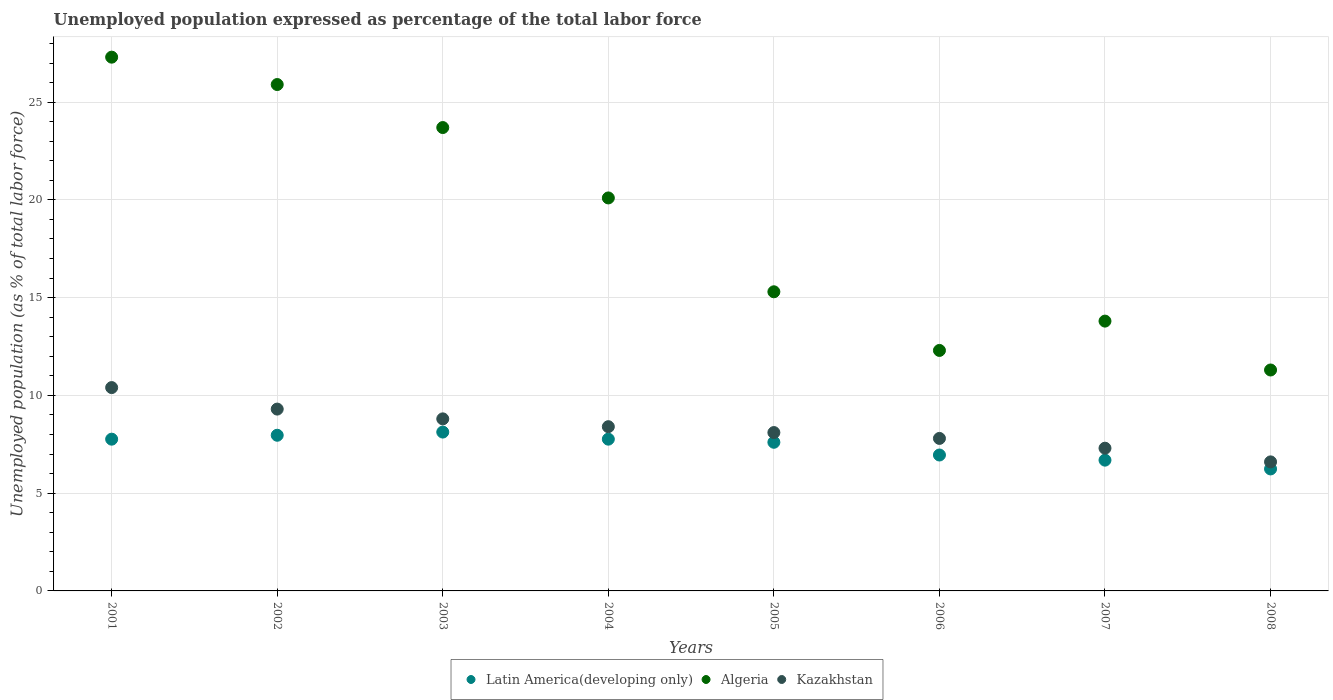How many different coloured dotlines are there?
Keep it short and to the point. 3. Is the number of dotlines equal to the number of legend labels?
Ensure brevity in your answer.  Yes. What is the unemployment in in Latin America(developing only) in 2008?
Your answer should be compact. 6.24. Across all years, what is the maximum unemployment in in Algeria?
Your answer should be very brief. 27.3. Across all years, what is the minimum unemployment in in Algeria?
Give a very brief answer. 11.3. What is the total unemployment in in Latin America(developing only) in the graph?
Provide a short and direct response. 59.09. What is the difference between the unemployment in in Latin America(developing only) in 2004 and that in 2005?
Offer a terse response. 0.16. What is the difference between the unemployment in in Kazakhstan in 2006 and the unemployment in in Algeria in 2002?
Offer a very short reply. -18.1. What is the average unemployment in in Latin America(developing only) per year?
Your response must be concise. 7.39. In the year 2003, what is the difference between the unemployment in in Algeria and unemployment in in Kazakhstan?
Keep it short and to the point. 14.9. In how many years, is the unemployment in in Algeria greater than 15 %?
Your response must be concise. 5. What is the ratio of the unemployment in in Algeria in 2005 to that in 2008?
Offer a terse response. 1.35. Is the difference between the unemployment in in Algeria in 2001 and 2007 greater than the difference between the unemployment in in Kazakhstan in 2001 and 2007?
Provide a succinct answer. Yes. What is the difference between the highest and the second highest unemployment in in Algeria?
Make the answer very short. 1.4. What is the difference between the highest and the lowest unemployment in in Kazakhstan?
Make the answer very short. 3.8. In how many years, is the unemployment in in Algeria greater than the average unemployment in in Algeria taken over all years?
Provide a short and direct response. 4. Is the unemployment in in Latin America(developing only) strictly greater than the unemployment in in Kazakhstan over the years?
Your answer should be very brief. No. How many dotlines are there?
Provide a short and direct response. 3. Does the graph contain any zero values?
Your answer should be very brief. No. Does the graph contain grids?
Offer a terse response. Yes. Where does the legend appear in the graph?
Your answer should be very brief. Bottom center. How are the legend labels stacked?
Provide a succinct answer. Horizontal. What is the title of the graph?
Offer a very short reply. Unemployed population expressed as percentage of the total labor force. What is the label or title of the X-axis?
Your response must be concise. Years. What is the label or title of the Y-axis?
Your answer should be compact. Unemployed population (as % of total labor force). What is the Unemployed population (as % of total labor force) of Latin America(developing only) in 2001?
Your answer should be compact. 7.76. What is the Unemployed population (as % of total labor force) of Algeria in 2001?
Provide a succinct answer. 27.3. What is the Unemployed population (as % of total labor force) in Kazakhstan in 2001?
Provide a short and direct response. 10.4. What is the Unemployed population (as % of total labor force) in Latin America(developing only) in 2002?
Make the answer very short. 7.96. What is the Unemployed population (as % of total labor force) of Algeria in 2002?
Offer a terse response. 25.9. What is the Unemployed population (as % of total labor force) of Kazakhstan in 2002?
Ensure brevity in your answer.  9.3. What is the Unemployed population (as % of total labor force) in Latin America(developing only) in 2003?
Make the answer very short. 8.12. What is the Unemployed population (as % of total labor force) of Algeria in 2003?
Your answer should be compact. 23.7. What is the Unemployed population (as % of total labor force) in Kazakhstan in 2003?
Provide a succinct answer. 8.8. What is the Unemployed population (as % of total labor force) of Latin America(developing only) in 2004?
Give a very brief answer. 7.76. What is the Unemployed population (as % of total labor force) of Algeria in 2004?
Provide a short and direct response. 20.1. What is the Unemployed population (as % of total labor force) of Kazakhstan in 2004?
Make the answer very short. 8.4. What is the Unemployed population (as % of total labor force) of Latin America(developing only) in 2005?
Your answer should be compact. 7.6. What is the Unemployed population (as % of total labor force) of Algeria in 2005?
Offer a terse response. 15.3. What is the Unemployed population (as % of total labor force) in Kazakhstan in 2005?
Offer a terse response. 8.1. What is the Unemployed population (as % of total labor force) of Latin America(developing only) in 2006?
Your answer should be compact. 6.95. What is the Unemployed population (as % of total labor force) of Algeria in 2006?
Your answer should be compact. 12.3. What is the Unemployed population (as % of total labor force) in Kazakhstan in 2006?
Give a very brief answer. 7.8. What is the Unemployed population (as % of total labor force) of Latin America(developing only) in 2007?
Ensure brevity in your answer.  6.69. What is the Unemployed population (as % of total labor force) of Algeria in 2007?
Provide a short and direct response. 13.8. What is the Unemployed population (as % of total labor force) in Kazakhstan in 2007?
Make the answer very short. 7.3. What is the Unemployed population (as % of total labor force) of Latin America(developing only) in 2008?
Your response must be concise. 6.24. What is the Unemployed population (as % of total labor force) of Algeria in 2008?
Ensure brevity in your answer.  11.3. What is the Unemployed population (as % of total labor force) in Kazakhstan in 2008?
Offer a very short reply. 6.6. Across all years, what is the maximum Unemployed population (as % of total labor force) of Latin America(developing only)?
Provide a short and direct response. 8.12. Across all years, what is the maximum Unemployed population (as % of total labor force) of Algeria?
Your answer should be very brief. 27.3. Across all years, what is the maximum Unemployed population (as % of total labor force) of Kazakhstan?
Give a very brief answer. 10.4. Across all years, what is the minimum Unemployed population (as % of total labor force) of Latin America(developing only)?
Offer a very short reply. 6.24. Across all years, what is the minimum Unemployed population (as % of total labor force) of Algeria?
Ensure brevity in your answer.  11.3. Across all years, what is the minimum Unemployed population (as % of total labor force) in Kazakhstan?
Give a very brief answer. 6.6. What is the total Unemployed population (as % of total labor force) in Latin America(developing only) in the graph?
Keep it short and to the point. 59.09. What is the total Unemployed population (as % of total labor force) of Algeria in the graph?
Keep it short and to the point. 149.7. What is the total Unemployed population (as % of total labor force) of Kazakhstan in the graph?
Ensure brevity in your answer.  66.7. What is the difference between the Unemployed population (as % of total labor force) in Latin America(developing only) in 2001 and that in 2002?
Your answer should be very brief. -0.2. What is the difference between the Unemployed population (as % of total labor force) in Latin America(developing only) in 2001 and that in 2003?
Offer a terse response. -0.36. What is the difference between the Unemployed population (as % of total labor force) in Kazakhstan in 2001 and that in 2003?
Keep it short and to the point. 1.6. What is the difference between the Unemployed population (as % of total labor force) of Latin America(developing only) in 2001 and that in 2004?
Your response must be concise. -0. What is the difference between the Unemployed population (as % of total labor force) of Latin America(developing only) in 2001 and that in 2005?
Keep it short and to the point. 0.16. What is the difference between the Unemployed population (as % of total labor force) in Kazakhstan in 2001 and that in 2005?
Ensure brevity in your answer.  2.3. What is the difference between the Unemployed population (as % of total labor force) of Latin America(developing only) in 2001 and that in 2006?
Your answer should be compact. 0.81. What is the difference between the Unemployed population (as % of total labor force) of Algeria in 2001 and that in 2006?
Give a very brief answer. 15. What is the difference between the Unemployed population (as % of total labor force) of Latin America(developing only) in 2001 and that in 2007?
Your response must be concise. 1.07. What is the difference between the Unemployed population (as % of total labor force) in Kazakhstan in 2001 and that in 2007?
Ensure brevity in your answer.  3.1. What is the difference between the Unemployed population (as % of total labor force) of Latin America(developing only) in 2001 and that in 2008?
Offer a very short reply. 1.52. What is the difference between the Unemployed population (as % of total labor force) of Algeria in 2001 and that in 2008?
Provide a short and direct response. 16. What is the difference between the Unemployed population (as % of total labor force) of Kazakhstan in 2001 and that in 2008?
Your answer should be compact. 3.8. What is the difference between the Unemployed population (as % of total labor force) in Latin America(developing only) in 2002 and that in 2003?
Provide a succinct answer. -0.16. What is the difference between the Unemployed population (as % of total labor force) in Algeria in 2002 and that in 2003?
Give a very brief answer. 2.2. What is the difference between the Unemployed population (as % of total labor force) in Kazakhstan in 2002 and that in 2003?
Give a very brief answer. 0.5. What is the difference between the Unemployed population (as % of total labor force) of Latin America(developing only) in 2002 and that in 2004?
Provide a short and direct response. 0.2. What is the difference between the Unemployed population (as % of total labor force) of Algeria in 2002 and that in 2004?
Keep it short and to the point. 5.8. What is the difference between the Unemployed population (as % of total labor force) in Latin America(developing only) in 2002 and that in 2005?
Your answer should be compact. 0.36. What is the difference between the Unemployed population (as % of total labor force) of Latin America(developing only) in 2002 and that in 2006?
Your answer should be very brief. 1.01. What is the difference between the Unemployed population (as % of total labor force) of Kazakhstan in 2002 and that in 2006?
Offer a very short reply. 1.5. What is the difference between the Unemployed population (as % of total labor force) of Latin America(developing only) in 2002 and that in 2007?
Make the answer very short. 1.27. What is the difference between the Unemployed population (as % of total labor force) in Kazakhstan in 2002 and that in 2007?
Ensure brevity in your answer.  2. What is the difference between the Unemployed population (as % of total labor force) in Latin America(developing only) in 2002 and that in 2008?
Provide a short and direct response. 1.72. What is the difference between the Unemployed population (as % of total labor force) of Algeria in 2002 and that in 2008?
Give a very brief answer. 14.6. What is the difference between the Unemployed population (as % of total labor force) in Latin America(developing only) in 2003 and that in 2004?
Offer a terse response. 0.36. What is the difference between the Unemployed population (as % of total labor force) of Kazakhstan in 2003 and that in 2004?
Ensure brevity in your answer.  0.4. What is the difference between the Unemployed population (as % of total labor force) in Latin America(developing only) in 2003 and that in 2005?
Keep it short and to the point. 0.52. What is the difference between the Unemployed population (as % of total labor force) in Kazakhstan in 2003 and that in 2005?
Make the answer very short. 0.7. What is the difference between the Unemployed population (as % of total labor force) in Latin America(developing only) in 2003 and that in 2006?
Ensure brevity in your answer.  1.17. What is the difference between the Unemployed population (as % of total labor force) in Latin America(developing only) in 2003 and that in 2007?
Provide a short and direct response. 1.44. What is the difference between the Unemployed population (as % of total labor force) in Algeria in 2003 and that in 2007?
Offer a very short reply. 9.9. What is the difference between the Unemployed population (as % of total labor force) in Latin America(developing only) in 2003 and that in 2008?
Your response must be concise. 1.89. What is the difference between the Unemployed population (as % of total labor force) in Algeria in 2003 and that in 2008?
Your answer should be very brief. 12.4. What is the difference between the Unemployed population (as % of total labor force) in Latin America(developing only) in 2004 and that in 2005?
Your answer should be very brief. 0.16. What is the difference between the Unemployed population (as % of total labor force) in Algeria in 2004 and that in 2005?
Give a very brief answer. 4.8. What is the difference between the Unemployed population (as % of total labor force) in Kazakhstan in 2004 and that in 2005?
Your response must be concise. 0.3. What is the difference between the Unemployed population (as % of total labor force) in Latin America(developing only) in 2004 and that in 2006?
Offer a terse response. 0.81. What is the difference between the Unemployed population (as % of total labor force) of Kazakhstan in 2004 and that in 2006?
Give a very brief answer. 0.6. What is the difference between the Unemployed population (as % of total labor force) in Latin America(developing only) in 2004 and that in 2007?
Your answer should be compact. 1.07. What is the difference between the Unemployed population (as % of total labor force) of Algeria in 2004 and that in 2007?
Offer a terse response. 6.3. What is the difference between the Unemployed population (as % of total labor force) in Latin America(developing only) in 2004 and that in 2008?
Offer a very short reply. 1.52. What is the difference between the Unemployed population (as % of total labor force) of Latin America(developing only) in 2005 and that in 2006?
Your answer should be compact. 0.65. What is the difference between the Unemployed population (as % of total labor force) of Algeria in 2005 and that in 2006?
Provide a succinct answer. 3. What is the difference between the Unemployed population (as % of total labor force) of Latin America(developing only) in 2005 and that in 2007?
Keep it short and to the point. 0.91. What is the difference between the Unemployed population (as % of total labor force) of Algeria in 2005 and that in 2007?
Your response must be concise. 1.5. What is the difference between the Unemployed population (as % of total labor force) of Latin America(developing only) in 2005 and that in 2008?
Provide a succinct answer. 1.36. What is the difference between the Unemployed population (as % of total labor force) of Algeria in 2005 and that in 2008?
Offer a very short reply. 4. What is the difference between the Unemployed population (as % of total labor force) in Latin America(developing only) in 2006 and that in 2007?
Your response must be concise. 0.26. What is the difference between the Unemployed population (as % of total labor force) of Kazakhstan in 2006 and that in 2007?
Offer a terse response. 0.5. What is the difference between the Unemployed population (as % of total labor force) of Latin America(developing only) in 2006 and that in 2008?
Provide a succinct answer. 0.71. What is the difference between the Unemployed population (as % of total labor force) in Algeria in 2006 and that in 2008?
Offer a very short reply. 1. What is the difference between the Unemployed population (as % of total labor force) of Latin America(developing only) in 2007 and that in 2008?
Provide a succinct answer. 0.45. What is the difference between the Unemployed population (as % of total labor force) in Kazakhstan in 2007 and that in 2008?
Provide a succinct answer. 0.7. What is the difference between the Unemployed population (as % of total labor force) of Latin America(developing only) in 2001 and the Unemployed population (as % of total labor force) of Algeria in 2002?
Your answer should be very brief. -18.14. What is the difference between the Unemployed population (as % of total labor force) of Latin America(developing only) in 2001 and the Unemployed population (as % of total labor force) of Kazakhstan in 2002?
Offer a terse response. -1.54. What is the difference between the Unemployed population (as % of total labor force) in Latin America(developing only) in 2001 and the Unemployed population (as % of total labor force) in Algeria in 2003?
Your answer should be compact. -15.94. What is the difference between the Unemployed population (as % of total labor force) of Latin America(developing only) in 2001 and the Unemployed population (as % of total labor force) of Kazakhstan in 2003?
Your answer should be compact. -1.04. What is the difference between the Unemployed population (as % of total labor force) in Latin America(developing only) in 2001 and the Unemployed population (as % of total labor force) in Algeria in 2004?
Offer a terse response. -12.34. What is the difference between the Unemployed population (as % of total labor force) in Latin America(developing only) in 2001 and the Unemployed population (as % of total labor force) in Kazakhstan in 2004?
Keep it short and to the point. -0.64. What is the difference between the Unemployed population (as % of total labor force) in Algeria in 2001 and the Unemployed population (as % of total labor force) in Kazakhstan in 2004?
Provide a short and direct response. 18.9. What is the difference between the Unemployed population (as % of total labor force) of Latin America(developing only) in 2001 and the Unemployed population (as % of total labor force) of Algeria in 2005?
Make the answer very short. -7.54. What is the difference between the Unemployed population (as % of total labor force) in Latin America(developing only) in 2001 and the Unemployed population (as % of total labor force) in Kazakhstan in 2005?
Make the answer very short. -0.34. What is the difference between the Unemployed population (as % of total labor force) of Algeria in 2001 and the Unemployed population (as % of total labor force) of Kazakhstan in 2005?
Your answer should be compact. 19.2. What is the difference between the Unemployed population (as % of total labor force) in Latin America(developing only) in 2001 and the Unemployed population (as % of total labor force) in Algeria in 2006?
Ensure brevity in your answer.  -4.54. What is the difference between the Unemployed population (as % of total labor force) of Latin America(developing only) in 2001 and the Unemployed population (as % of total labor force) of Kazakhstan in 2006?
Ensure brevity in your answer.  -0.04. What is the difference between the Unemployed population (as % of total labor force) in Algeria in 2001 and the Unemployed population (as % of total labor force) in Kazakhstan in 2006?
Make the answer very short. 19.5. What is the difference between the Unemployed population (as % of total labor force) in Latin America(developing only) in 2001 and the Unemployed population (as % of total labor force) in Algeria in 2007?
Offer a very short reply. -6.04. What is the difference between the Unemployed population (as % of total labor force) in Latin America(developing only) in 2001 and the Unemployed population (as % of total labor force) in Kazakhstan in 2007?
Provide a short and direct response. 0.46. What is the difference between the Unemployed population (as % of total labor force) of Algeria in 2001 and the Unemployed population (as % of total labor force) of Kazakhstan in 2007?
Provide a short and direct response. 20. What is the difference between the Unemployed population (as % of total labor force) in Latin America(developing only) in 2001 and the Unemployed population (as % of total labor force) in Algeria in 2008?
Your answer should be very brief. -3.54. What is the difference between the Unemployed population (as % of total labor force) in Latin America(developing only) in 2001 and the Unemployed population (as % of total labor force) in Kazakhstan in 2008?
Keep it short and to the point. 1.16. What is the difference between the Unemployed population (as % of total labor force) of Algeria in 2001 and the Unemployed population (as % of total labor force) of Kazakhstan in 2008?
Offer a terse response. 20.7. What is the difference between the Unemployed population (as % of total labor force) in Latin America(developing only) in 2002 and the Unemployed population (as % of total labor force) in Algeria in 2003?
Offer a terse response. -15.74. What is the difference between the Unemployed population (as % of total labor force) of Latin America(developing only) in 2002 and the Unemployed population (as % of total labor force) of Kazakhstan in 2003?
Your answer should be very brief. -0.84. What is the difference between the Unemployed population (as % of total labor force) of Latin America(developing only) in 2002 and the Unemployed population (as % of total labor force) of Algeria in 2004?
Make the answer very short. -12.14. What is the difference between the Unemployed population (as % of total labor force) in Latin America(developing only) in 2002 and the Unemployed population (as % of total labor force) in Kazakhstan in 2004?
Ensure brevity in your answer.  -0.44. What is the difference between the Unemployed population (as % of total labor force) of Algeria in 2002 and the Unemployed population (as % of total labor force) of Kazakhstan in 2004?
Your response must be concise. 17.5. What is the difference between the Unemployed population (as % of total labor force) in Latin America(developing only) in 2002 and the Unemployed population (as % of total labor force) in Algeria in 2005?
Your response must be concise. -7.34. What is the difference between the Unemployed population (as % of total labor force) of Latin America(developing only) in 2002 and the Unemployed population (as % of total labor force) of Kazakhstan in 2005?
Your response must be concise. -0.14. What is the difference between the Unemployed population (as % of total labor force) in Latin America(developing only) in 2002 and the Unemployed population (as % of total labor force) in Algeria in 2006?
Ensure brevity in your answer.  -4.34. What is the difference between the Unemployed population (as % of total labor force) in Latin America(developing only) in 2002 and the Unemployed population (as % of total labor force) in Kazakhstan in 2006?
Provide a short and direct response. 0.16. What is the difference between the Unemployed population (as % of total labor force) in Algeria in 2002 and the Unemployed population (as % of total labor force) in Kazakhstan in 2006?
Make the answer very short. 18.1. What is the difference between the Unemployed population (as % of total labor force) in Latin America(developing only) in 2002 and the Unemployed population (as % of total labor force) in Algeria in 2007?
Provide a succinct answer. -5.84. What is the difference between the Unemployed population (as % of total labor force) in Latin America(developing only) in 2002 and the Unemployed population (as % of total labor force) in Kazakhstan in 2007?
Provide a succinct answer. 0.66. What is the difference between the Unemployed population (as % of total labor force) of Algeria in 2002 and the Unemployed population (as % of total labor force) of Kazakhstan in 2007?
Your answer should be very brief. 18.6. What is the difference between the Unemployed population (as % of total labor force) in Latin America(developing only) in 2002 and the Unemployed population (as % of total labor force) in Algeria in 2008?
Your answer should be compact. -3.34. What is the difference between the Unemployed population (as % of total labor force) of Latin America(developing only) in 2002 and the Unemployed population (as % of total labor force) of Kazakhstan in 2008?
Your response must be concise. 1.36. What is the difference between the Unemployed population (as % of total labor force) in Algeria in 2002 and the Unemployed population (as % of total labor force) in Kazakhstan in 2008?
Your answer should be very brief. 19.3. What is the difference between the Unemployed population (as % of total labor force) of Latin America(developing only) in 2003 and the Unemployed population (as % of total labor force) of Algeria in 2004?
Keep it short and to the point. -11.98. What is the difference between the Unemployed population (as % of total labor force) of Latin America(developing only) in 2003 and the Unemployed population (as % of total labor force) of Kazakhstan in 2004?
Provide a short and direct response. -0.28. What is the difference between the Unemployed population (as % of total labor force) of Algeria in 2003 and the Unemployed population (as % of total labor force) of Kazakhstan in 2004?
Your answer should be very brief. 15.3. What is the difference between the Unemployed population (as % of total labor force) in Latin America(developing only) in 2003 and the Unemployed population (as % of total labor force) in Algeria in 2005?
Give a very brief answer. -7.18. What is the difference between the Unemployed population (as % of total labor force) in Latin America(developing only) in 2003 and the Unemployed population (as % of total labor force) in Kazakhstan in 2005?
Offer a terse response. 0.02. What is the difference between the Unemployed population (as % of total labor force) in Latin America(developing only) in 2003 and the Unemployed population (as % of total labor force) in Algeria in 2006?
Make the answer very short. -4.18. What is the difference between the Unemployed population (as % of total labor force) of Latin America(developing only) in 2003 and the Unemployed population (as % of total labor force) of Kazakhstan in 2006?
Offer a terse response. 0.32. What is the difference between the Unemployed population (as % of total labor force) in Latin America(developing only) in 2003 and the Unemployed population (as % of total labor force) in Algeria in 2007?
Ensure brevity in your answer.  -5.68. What is the difference between the Unemployed population (as % of total labor force) in Latin America(developing only) in 2003 and the Unemployed population (as % of total labor force) in Kazakhstan in 2007?
Offer a terse response. 0.82. What is the difference between the Unemployed population (as % of total labor force) in Latin America(developing only) in 2003 and the Unemployed population (as % of total labor force) in Algeria in 2008?
Give a very brief answer. -3.18. What is the difference between the Unemployed population (as % of total labor force) of Latin America(developing only) in 2003 and the Unemployed population (as % of total labor force) of Kazakhstan in 2008?
Provide a succinct answer. 1.52. What is the difference between the Unemployed population (as % of total labor force) in Algeria in 2003 and the Unemployed population (as % of total labor force) in Kazakhstan in 2008?
Make the answer very short. 17.1. What is the difference between the Unemployed population (as % of total labor force) in Latin America(developing only) in 2004 and the Unemployed population (as % of total labor force) in Algeria in 2005?
Provide a succinct answer. -7.54. What is the difference between the Unemployed population (as % of total labor force) in Latin America(developing only) in 2004 and the Unemployed population (as % of total labor force) in Kazakhstan in 2005?
Provide a short and direct response. -0.34. What is the difference between the Unemployed population (as % of total labor force) of Latin America(developing only) in 2004 and the Unemployed population (as % of total labor force) of Algeria in 2006?
Your response must be concise. -4.54. What is the difference between the Unemployed population (as % of total labor force) of Latin America(developing only) in 2004 and the Unemployed population (as % of total labor force) of Kazakhstan in 2006?
Offer a very short reply. -0.04. What is the difference between the Unemployed population (as % of total labor force) of Algeria in 2004 and the Unemployed population (as % of total labor force) of Kazakhstan in 2006?
Keep it short and to the point. 12.3. What is the difference between the Unemployed population (as % of total labor force) in Latin America(developing only) in 2004 and the Unemployed population (as % of total labor force) in Algeria in 2007?
Offer a very short reply. -6.04. What is the difference between the Unemployed population (as % of total labor force) of Latin America(developing only) in 2004 and the Unemployed population (as % of total labor force) of Kazakhstan in 2007?
Offer a terse response. 0.46. What is the difference between the Unemployed population (as % of total labor force) of Algeria in 2004 and the Unemployed population (as % of total labor force) of Kazakhstan in 2007?
Ensure brevity in your answer.  12.8. What is the difference between the Unemployed population (as % of total labor force) of Latin America(developing only) in 2004 and the Unemployed population (as % of total labor force) of Algeria in 2008?
Provide a short and direct response. -3.54. What is the difference between the Unemployed population (as % of total labor force) in Latin America(developing only) in 2004 and the Unemployed population (as % of total labor force) in Kazakhstan in 2008?
Give a very brief answer. 1.16. What is the difference between the Unemployed population (as % of total labor force) in Algeria in 2004 and the Unemployed population (as % of total labor force) in Kazakhstan in 2008?
Provide a short and direct response. 13.5. What is the difference between the Unemployed population (as % of total labor force) of Latin America(developing only) in 2005 and the Unemployed population (as % of total labor force) of Algeria in 2006?
Make the answer very short. -4.7. What is the difference between the Unemployed population (as % of total labor force) of Latin America(developing only) in 2005 and the Unemployed population (as % of total labor force) of Kazakhstan in 2006?
Keep it short and to the point. -0.2. What is the difference between the Unemployed population (as % of total labor force) of Latin America(developing only) in 2005 and the Unemployed population (as % of total labor force) of Algeria in 2007?
Your answer should be compact. -6.2. What is the difference between the Unemployed population (as % of total labor force) in Latin America(developing only) in 2005 and the Unemployed population (as % of total labor force) in Kazakhstan in 2007?
Your response must be concise. 0.3. What is the difference between the Unemployed population (as % of total labor force) in Algeria in 2005 and the Unemployed population (as % of total labor force) in Kazakhstan in 2007?
Your answer should be compact. 8. What is the difference between the Unemployed population (as % of total labor force) in Latin America(developing only) in 2005 and the Unemployed population (as % of total labor force) in Algeria in 2008?
Your response must be concise. -3.7. What is the difference between the Unemployed population (as % of total labor force) in Latin America(developing only) in 2006 and the Unemployed population (as % of total labor force) in Algeria in 2007?
Ensure brevity in your answer.  -6.85. What is the difference between the Unemployed population (as % of total labor force) in Latin America(developing only) in 2006 and the Unemployed population (as % of total labor force) in Kazakhstan in 2007?
Ensure brevity in your answer.  -0.35. What is the difference between the Unemployed population (as % of total labor force) in Algeria in 2006 and the Unemployed population (as % of total labor force) in Kazakhstan in 2007?
Your answer should be compact. 5. What is the difference between the Unemployed population (as % of total labor force) of Latin America(developing only) in 2006 and the Unemployed population (as % of total labor force) of Algeria in 2008?
Your answer should be very brief. -4.35. What is the difference between the Unemployed population (as % of total labor force) in Latin America(developing only) in 2006 and the Unemployed population (as % of total labor force) in Kazakhstan in 2008?
Your response must be concise. 0.35. What is the difference between the Unemployed population (as % of total labor force) in Algeria in 2006 and the Unemployed population (as % of total labor force) in Kazakhstan in 2008?
Your answer should be compact. 5.7. What is the difference between the Unemployed population (as % of total labor force) in Latin America(developing only) in 2007 and the Unemployed population (as % of total labor force) in Algeria in 2008?
Give a very brief answer. -4.61. What is the difference between the Unemployed population (as % of total labor force) in Latin America(developing only) in 2007 and the Unemployed population (as % of total labor force) in Kazakhstan in 2008?
Offer a terse response. 0.09. What is the difference between the Unemployed population (as % of total labor force) in Algeria in 2007 and the Unemployed population (as % of total labor force) in Kazakhstan in 2008?
Offer a very short reply. 7.2. What is the average Unemployed population (as % of total labor force) in Latin America(developing only) per year?
Provide a succinct answer. 7.39. What is the average Unemployed population (as % of total labor force) in Algeria per year?
Your response must be concise. 18.71. What is the average Unemployed population (as % of total labor force) in Kazakhstan per year?
Your answer should be very brief. 8.34. In the year 2001, what is the difference between the Unemployed population (as % of total labor force) in Latin America(developing only) and Unemployed population (as % of total labor force) in Algeria?
Make the answer very short. -19.54. In the year 2001, what is the difference between the Unemployed population (as % of total labor force) of Latin America(developing only) and Unemployed population (as % of total labor force) of Kazakhstan?
Make the answer very short. -2.64. In the year 2002, what is the difference between the Unemployed population (as % of total labor force) of Latin America(developing only) and Unemployed population (as % of total labor force) of Algeria?
Your answer should be very brief. -17.94. In the year 2002, what is the difference between the Unemployed population (as % of total labor force) of Latin America(developing only) and Unemployed population (as % of total labor force) of Kazakhstan?
Your answer should be very brief. -1.34. In the year 2002, what is the difference between the Unemployed population (as % of total labor force) of Algeria and Unemployed population (as % of total labor force) of Kazakhstan?
Keep it short and to the point. 16.6. In the year 2003, what is the difference between the Unemployed population (as % of total labor force) of Latin America(developing only) and Unemployed population (as % of total labor force) of Algeria?
Offer a very short reply. -15.58. In the year 2003, what is the difference between the Unemployed population (as % of total labor force) of Latin America(developing only) and Unemployed population (as % of total labor force) of Kazakhstan?
Offer a terse response. -0.68. In the year 2003, what is the difference between the Unemployed population (as % of total labor force) of Algeria and Unemployed population (as % of total labor force) of Kazakhstan?
Make the answer very short. 14.9. In the year 2004, what is the difference between the Unemployed population (as % of total labor force) in Latin America(developing only) and Unemployed population (as % of total labor force) in Algeria?
Keep it short and to the point. -12.34. In the year 2004, what is the difference between the Unemployed population (as % of total labor force) of Latin America(developing only) and Unemployed population (as % of total labor force) of Kazakhstan?
Keep it short and to the point. -0.64. In the year 2005, what is the difference between the Unemployed population (as % of total labor force) in Latin America(developing only) and Unemployed population (as % of total labor force) in Algeria?
Ensure brevity in your answer.  -7.7. In the year 2005, what is the difference between the Unemployed population (as % of total labor force) of Latin America(developing only) and Unemployed population (as % of total labor force) of Kazakhstan?
Provide a succinct answer. -0.5. In the year 2006, what is the difference between the Unemployed population (as % of total labor force) of Latin America(developing only) and Unemployed population (as % of total labor force) of Algeria?
Your response must be concise. -5.35. In the year 2006, what is the difference between the Unemployed population (as % of total labor force) of Latin America(developing only) and Unemployed population (as % of total labor force) of Kazakhstan?
Keep it short and to the point. -0.85. In the year 2006, what is the difference between the Unemployed population (as % of total labor force) in Algeria and Unemployed population (as % of total labor force) in Kazakhstan?
Provide a succinct answer. 4.5. In the year 2007, what is the difference between the Unemployed population (as % of total labor force) in Latin America(developing only) and Unemployed population (as % of total labor force) in Algeria?
Offer a terse response. -7.11. In the year 2007, what is the difference between the Unemployed population (as % of total labor force) in Latin America(developing only) and Unemployed population (as % of total labor force) in Kazakhstan?
Your response must be concise. -0.61. In the year 2008, what is the difference between the Unemployed population (as % of total labor force) in Latin America(developing only) and Unemployed population (as % of total labor force) in Algeria?
Ensure brevity in your answer.  -5.06. In the year 2008, what is the difference between the Unemployed population (as % of total labor force) in Latin America(developing only) and Unemployed population (as % of total labor force) in Kazakhstan?
Provide a short and direct response. -0.36. What is the ratio of the Unemployed population (as % of total labor force) of Latin America(developing only) in 2001 to that in 2002?
Provide a short and direct response. 0.97. What is the ratio of the Unemployed population (as % of total labor force) in Algeria in 2001 to that in 2002?
Your answer should be very brief. 1.05. What is the ratio of the Unemployed population (as % of total labor force) of Kazakhstan in 2001 to that in 2002?
Your answer should be compact. 1.12. What is the ratio of the Unemployed population (as % of total labor force) of Latin America(developing only) in 2001 to that in 2003?
Your answer should be very brief. 0.96. What is the ratio of the Unemployed population (as % of total labor force) of Algeria in 2001 to that in 2003?
Offer a very short reply. 1.15. What is the ratio of the Unemployed population (as % of total labor force) of Kazakhstan in 2001 to that in 2003?
Your response must be concise. 1.18. What is the ratio of the Unemployed population (as % of total labor force) in Algeria in 2001 to that in 2004?
Your response must be concise. 1.36. What is the ratio of the Unemployed population (as % of total labor force) of Kazakhstan in 2001 to that in 2004?
Keep it short and to the point. 1.24. What is the ratio of the Unemployed population (as % of total labor force) of Latin America(developing only) in 2001 to that in 2005?
Your answer should be very brief. 1.02. What is the ratio of the Unemployed population (as % of total labor force) in Algeria in 2001 to that in 2005?
Give a very brief answer. 1.78. What is the ratio of the Unemployed population (as % of total labor force) of Kazakhstan in 2001 to that in 2005?
Your response must be concise. 1.28. What is the ratio of the Unemployed population (as % of total labor force) of Latin America(developing only) in 2001 to that in 2006?
Ensure brevity in your answer.  1.12. What is the ratio of the Unemployed population (as % of total labor force) of Algeria in 2001 to that in 2006?
Your answer should be compact. 2.22. What is the ratio of the Unemployed population (as % of total labor force) in Kazakhstan in 2001 to that in 2006?
Ensure brevity in your answer.  1.33. What is the ratio of the Unemployed population (as % of total labor force) of Latin America(developing only) in 2001 to that in 2007?
Keep it short and to the point. 1.16. What is the ratio of the Unemployed population (as % of total labor force) of Algeria in 2001 to that in 2007?
Provide a short and direct response. 1.98. What is the ratio of the Unemployed population (as % of total labor force) in Kazakhstan in 2001 to that in 2007?
Provide a short and direct response. 1.42. What is the ratio of the Unemployed population (as % of total labor force) of Latin America(developing only) in 2001 to that in 2008?
Your response must be concise. 1.24. What is the ratio of the Unemployed population (as % of total labor force) of Algeria in 2001 to that in 2008?
Your answer should be compact. 2.42. What is the ratio of the Unemployed population (as % of total labor force) of Kazakhstan in 2001 to that in 2008?
Your answer should be very brief. 1.58. What is the ratio of the Unemployed population (as % of total labor force) in Algeria in 2002 to that in 2003?
Offer a terse response. 1.09. What is the ratio of the Unemployed population (as % of total labor force) of Kazakhstan in 2002 to that in 2003?
Your response must be concise. 1.06. What is the ratio of the Unemployed population (as % of total labor force) in Latin America(developing only) in 2002 to that in 2004?
Offer a terse response. 1.03. What is the ratio of the Unemployed population (as % of total labor force) in Algeria in 2002 to that in 2004?
Provide a short and direct response. 1.29. What is the ratio of the Unemployed population (as % of total labor force) of Kazakhstan in 2002 to that in 2004?
Your answer should be compact. 1.11. What is the ratio of the Unemployed population (as % of total labor force) in Latin America(developing only) in 2002 to that in 2005?
Your answer should be very brief. 1.05. What is the ratio of the Unemployed population (as % of total labor force) of Algeria in 2002 to that in 2005?
Your answer should be very brief. 1.69. What is the ratio of the Unemployed population (as % of total labor force) in Kazakhstan in 2002 to that in 2005?
Your answer should be compact. 1.15. What is the ratio of the Unemployed population (as % of total labor force) in Latin America(developing only) in 2002 to that in 2006?
Offer a very short reply. 1.15. What is the ratio of the Unemployed population (as % of total labor force) of Algeria in 2002 to that in 2006?
Provide a succinct answer. 2.11. What is the ratio of the Unemployed population (as % of total labor force) of Kazakhstan in 2002 to that in 2006?
Give a very brief answer. 1.19. What is the ratio of the Unemployed population (as % of total labor force) of Latin America(developing only) in 2002 to that in 2007?
Offer a terse response. 1.19. What is the ratio of the Unemployed population (as % of total labor force) in Algeria in 2002 to that in 2007?
Offer a very short reply. 1.88. What is the ratio of the Unemployed population (as % of total labor force) of Kazakhstan in 2002 to that in 2007?
Offer a very short reply. 1.27. What is the ratio of the Unemployed population (as % of total labor force) of Latin America(developing only) in 2002 to that in 2008?
Offer a very short reply. 1.28. What is the ratio of the Unemployed population (as % of total labor force) of Algeria in 2002 to that in 2008?
Offer a very short reply. 2.29. What is the ratio of the Unemployed population (as % of total labor force) in Kazakhstan in 2002 to that in 2008?
Offer a terse response. 1.41. What is the ratio of the Unemployed population (as % of total labor force) in Latin America(developing only) in 2003 to that in 2004?
Your answer should be compact. 1.05. What is the ratio of the Unemployed population (as % of total labor force) in Algeria in 2003 to that in 2004?
Your response must be concise. 1.18. What is the ratio of the Unemployed population (as % of total labor force) of Kazakhstan in 2003 to that in 2004?
Give a very brief answer. 1.05. What is the ratio of the Unemployed population (as % of total labor force) of Latin America(developing only) in 2003 to that in 2005?
Offer a very short reply. 1.07. What is the ratio of the Unemployed population (as % of total labor force) of Algeria in 2003 to that in 2005?
Keep it short and to the point. 1.55. What is the ratio of the Unemployed population (as % of total labor force) in Kazakhstan in 2003 to that in 2005?
Offer a terse response. 1.09. What is the ratio of the Unemployed population (as % of total labor force) of Latin America(developing only) in 2003 to that in 2006?
Keep it short and to the point. 1.17. What is the ratio of the Unemployed population (as % of total labor force) in Algeria in 2003 to that in 2006?
Offer a terse response. 1.93. What is the ratio of the Unemployed population (as % of total labor force) of Kazakhstan in 2003 to that in 2006?
Provide a short and direct response. 1.13. What is the ratio of the Unemployed population (as % of total labor force) of Latin America(developing only) in 2003 to that in 2007?
Offer a very short reply. 1.21. What is the ratio of the Unemployed population (as % of total labor force) in Algeria in 2003 to that in 2007?
Provide a short and direct response. 1.72. What is the ratio of the Unemployed population (as % of total labor force) of Kazakhstan in 2003 to that in 2007?
Offer a terse response. 1.21. What is the ratio of the Unemployed population (as % of total labor force) of Latin America(developing only) in 2003 to that in 2008?
Your answer should be compact. 1.3. What is the ratio of the Unemployed population (as % of total labor force) in Algeria in 2003 to that in 2008?
Your answer should be compact. 2.1. What is the ratio of the Unemployed population (as % of total labor force) of Latin America(developing only) in 2004 to that in 2005?
Offer a terse response. 1.02. What is the ratio of the Unemployed population (as % of total labor force) in Algeria in 2004 to that in 2005?
Ensure brevity in your answer.  1.31. What is the ratio of the Unemployed population (as % of total labor force) in Latin America(developing only) in 2004 to that in 2006?
Make the answer very short. 1.12. What is the ratio of the Unemployed population (as % of total labor force) of Algeria in 2004 to that in 2006?
Ensure brevity in your answer.  1.63. What is the ratio of the Unemployed population (as % of total labor force) of Kazakhstan in 2004 to that in 2006?
Ensure brevity in your answer.  1.08. What is the ratio of the Unemployed population (as % of total labor force) of Latin America(developing only) in 2004 to that in 2007?
Offer a terse response. 1.16. What is the ratio of the Unemployed population (as % of total labor force) in Algeria in 2004 to that in 2007?
Offer a very short reply. 1.46. What is the ratio of the Unemployed population (as % of total labor force) of Kazakhstan in 2004 to that in 2007?
Your response must be concise. 1.15. What is the ratio of the Unemployed population (as % of total labor force) in Latin America(developing only) in 2004 to that in 2008?
Offer a very short reply. 1.24. What is the ratio of the Unemployed population (as % of total labor force) of Algeria in 2004 to that in 2008?
Give a very brief answer. 1.78. What is the ratio of the Unemployed population (as % of total labor force) of Kazakhstan in 2004 to that in 2008?
Your response must be concise. 1.27. What is the ratio of the Unemployed population (as % of total labor force) in Latin America(developing only) in 2005 to that in 2006?
Ensure brevity in your answer.  1.09. What is the ratio of the Unemployed population (as % of total labor force) of Algeria in 2005 to that in 2006?
Provide a succinct answer. 1.24. What is the ratio of the Unemployed population (as % of total labor force) of Latin America(developing only) in 2005 to that in 2007?
Ensure brevity in your answer.  1.14. What is the ratio of the Unemployed population (as % of total labor force) of Algeria in 2005 to that in 2007?
Keep it short and to the point. 1.11. What is the ratio of the Unemployed population (as % of total labor force) of Kazakhstan in 2005 to that in 2007?
Make the answer very short. 1.11. What is the ratio of the Unemployed population (as % of total labor force) of Latin America(developing only) in 2005 to that in 2008?
Your response must be concise. 1.22. What is the ratio of the Unemployed population (as % of total labor force) in Algeria in 2005 to that in 2008?
Give a very brief answer. 1.35. What is the ratio of the Unemployed population (as % of total labor force) in Kazakhstan in 2005 to that in 2008?
Offer a terse response. 1.23. What is the ratio of the Unemployed population (as % of total labor force) in Latin America(developing only) in 2006 to that in 2007?
Offer a terse response. 1.04. What is the ratio of the Unemployed population (as % of total labor force) of Algeria in 2006 to that in 2007?
Make the answer very short. 0.89. What is the ratio of the Unemployed population (as % of total labor force) in Kazakhstan in 2006 to that in 2007?
Provide a short and direct response. 1.07. What is the ratio of the Unemployed population (as % of total labor force) of Latin America(developing only) in 2006 to that in 2008?
Ensure brevity in your answer.  1.11. What is the ratio of the Unemployed population (as % of total labor force) in Algeria in 2006 to that in 2008?
Your answer should be very brief. 1.09. What is the ratio of the Unemployed population (as % of total labor force) in Kazakhstan in 2006 to that in 2008?
Your answer should be compact. 1.18. What is the ratio of the Unemployed population (as % of total labor force) of Latin America(developing only) in 2007 to that in 2008?
Give a very brief answer. 1.07. What is the ratio of the Unemployed population (as % of total labor force) in Algeria in 2007 to that in 2008?
Ensure brevity in your answer.  1.22. What is the ratio of the Unemployed population (as % of total labor force) of Kazakhstan in 2007 to that in 2008?
Offer a terse response. 1.11. What is the difference between the highest and the second highest Unemployed population (as % of total labor force) in Latin America(developing only)?
Your response must be concise. 0.16. What is the difference between the highest and the lowest Unemployed population (as % of total labor force) of Latin America(developing only)?
Make the answer very short. 1.89. What is the difference between the highest and the lowest Unemployed population (as % of total labor force) in Algeria?
Make the answer very short. 16. 